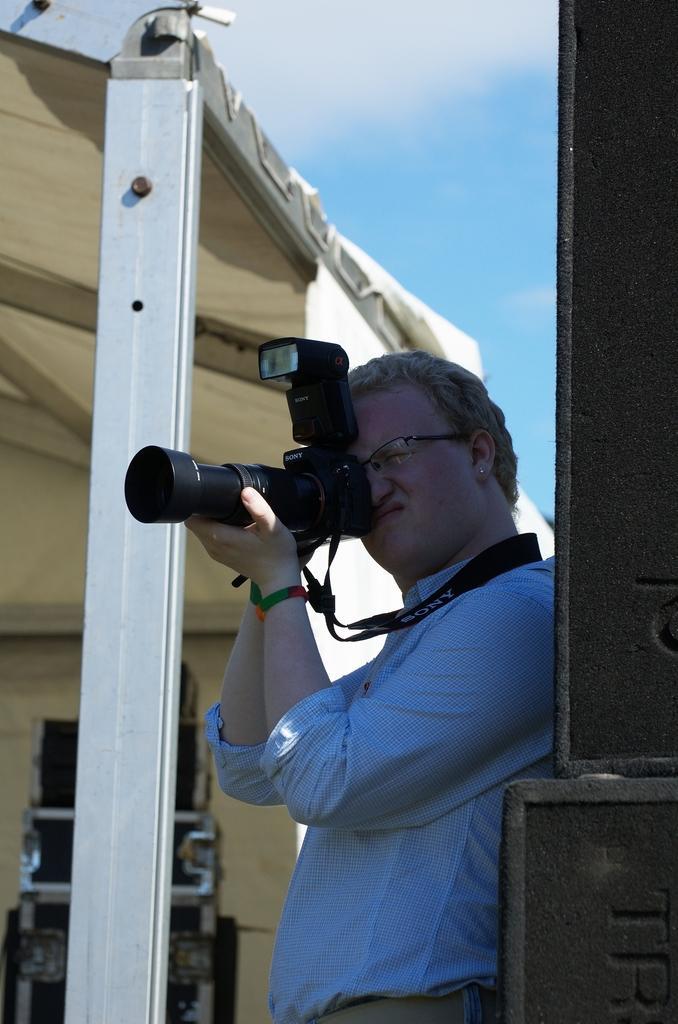How would you summarize this image in a sentence or two? In this image there is a person. There is a camera. There is shed in the background. There is a sky. 